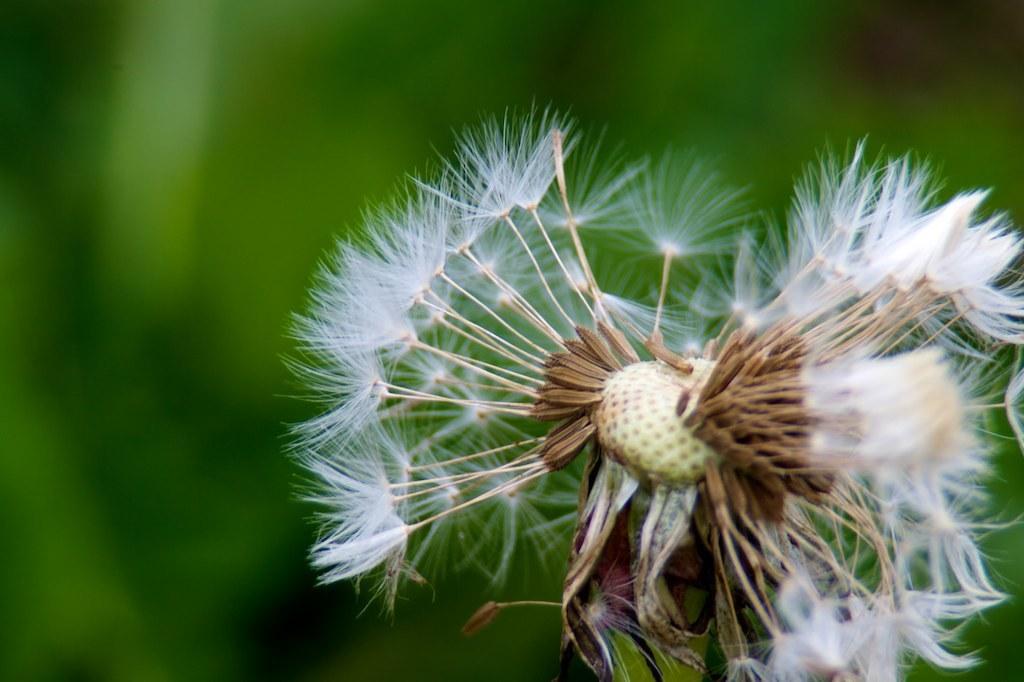In one or two sentences, can you explain what this image depicts? In the foreground of the picture there is a flower. The background is blurred. 